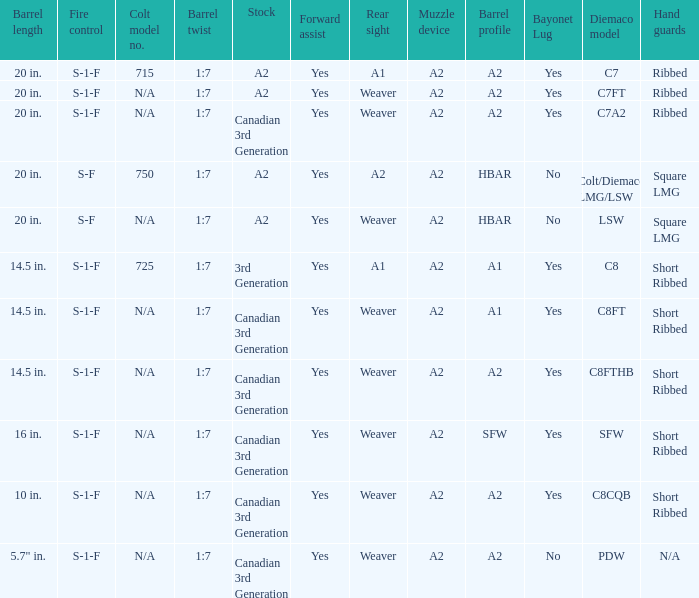Which Hand guards has a Barrel profile of a2 and a Rear sight of weaver? Ribbed, Ribbed, Short Ribbed, Short Ribbed, N/A. 